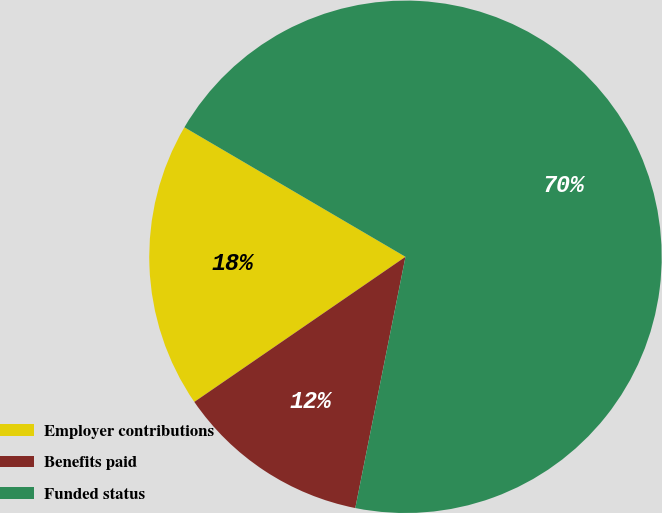<chart> <loc_0><loc_0><loc_500><loc_500><pie_chart><fcel>Employer contributions<fcel>Benefits paid<fcel>Funded status<nl><fcel>18.02%<fcel>12.28%<fcel>69.71%<nl></chart> 